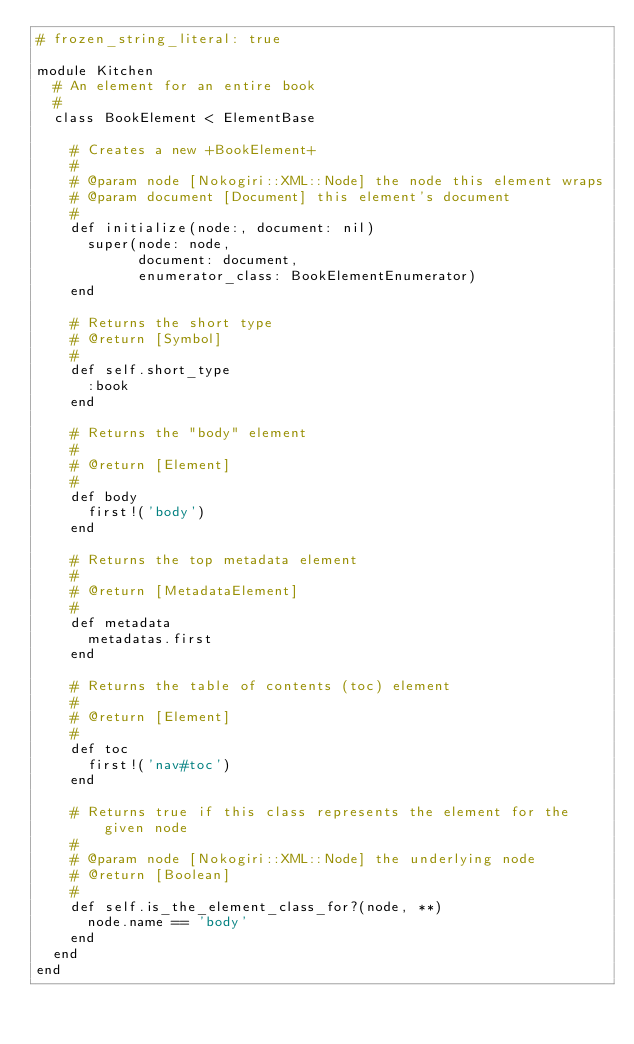Convert code to text. <code><loc_0><loc_0><loc_500><loc_500><_Ruby_># frozen_string_literal: true

module Kitchen
  # An element for an entire book
  #
  class BookElement < ElementBase

    # Creates a new +BookElement+
    #
    # @param node [Nokogiri::XML::Node] the node this element wraps
    # @param document [Document] this element's document
    #
    def initialize(node:, document: nil)
      super(node: node,
            document: document,
            enumerator_class: BookElementEnumerator)
    end

    # Returns the short type
    # @return [Symbol]
    #
    def self.short_type
      :book
    end

    # Returns the "body" element
    #
    # @return [Element]
    #
    def body
      first!('body')
    end

    # Returns the top metadata element
    #
    # @return [MetadataElement]
    #
    def metadata
      metadatas.first
    end

    # Returns the table of contents (toc) element
    #
    # @return [Element]
    #
    def toc
      first!('nav#toc')
    end

    # Returns true if this class represents the element for the given node
    #
    # @param node [Nokogiri::XML::Node] the underlying node
    # @return [Boolean]
    #
    def self.is_the_element_class_for?(node, **)
      node.name == 'body'
    end
  end
end
</code> 